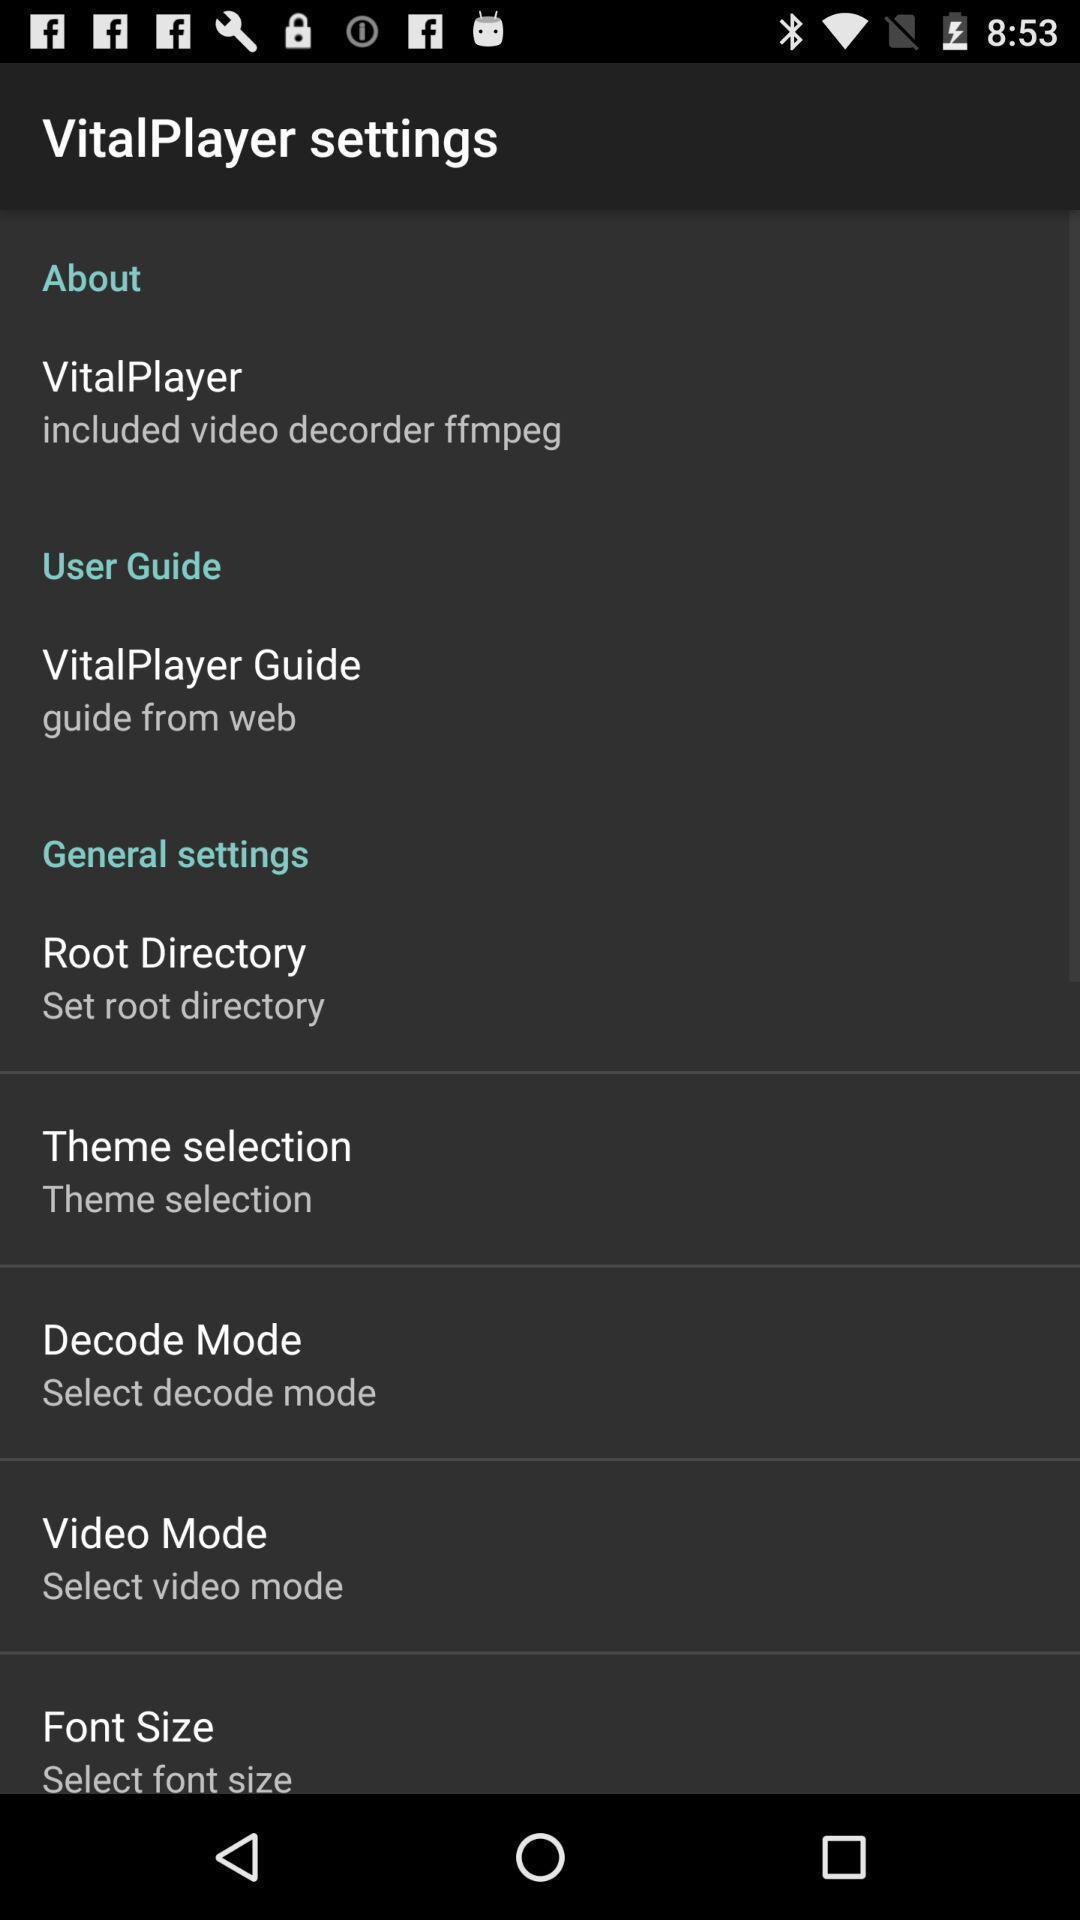What details can you identify in this image? Screen showing settings page. 